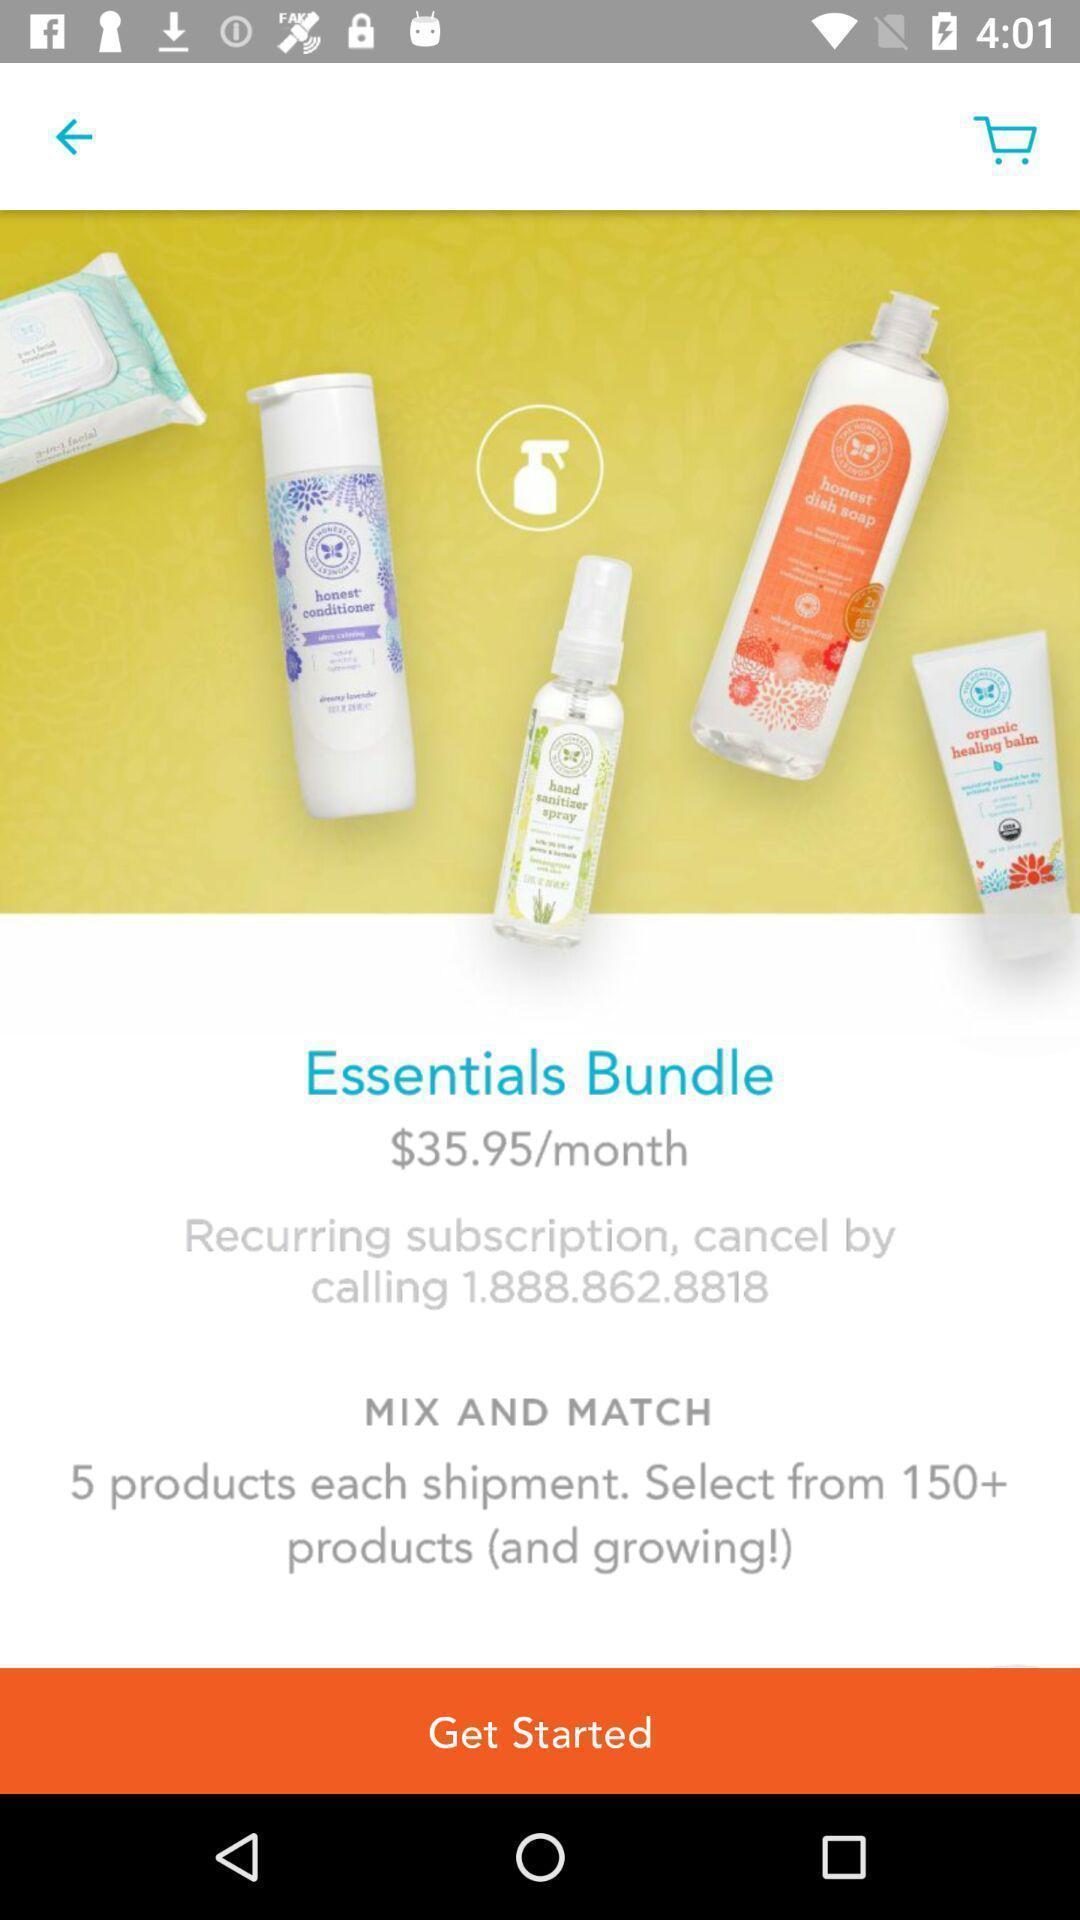Please provide a description for this image. Window displaying products to buy. 